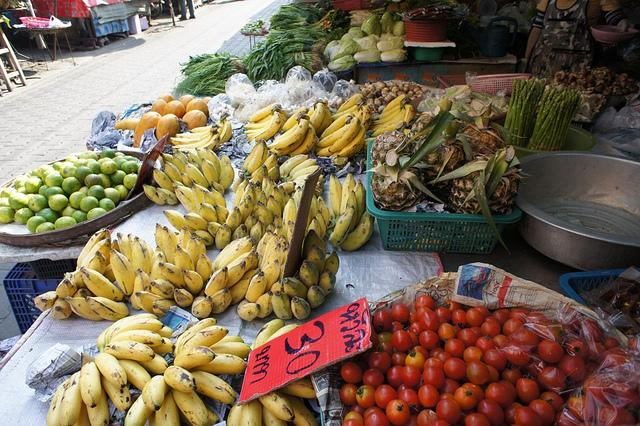What color are the sweet fruits? yellow 